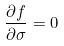Convert formula to latex. <formula><loc_0><loc_0><loc_500><loc_500>\frac { \partial f } { \partial \sigma } = 0</formula> 